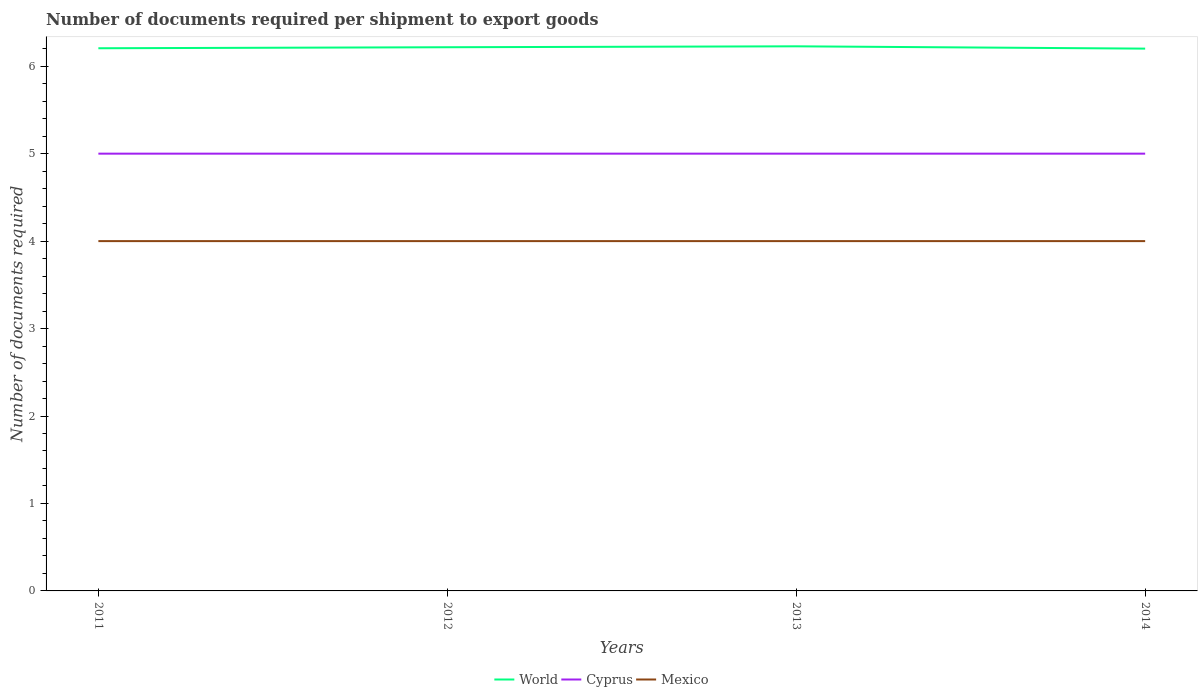How many different coloured lines are there?
Your response must be concise. 3. Does the line corresponding to World intersect with the line corresponding to Cyprus?
Make the answer very short. No. Is the number of lines equal to the number of legend labels?
Offer a terse response. Yes. Across all years, what is the maximum number of documents required per shipment to export goods in Mexico?
Offer a very short reply. 4. In which year was the number of documents required per shipment to export goods in World maximum?
Ensure brevity in your answer.  2014. What is the total number of documents required per shipment to export goods in World in the graph?
Give a very brief answer. 0.02. What is the difference between the highest and the second highest number of documents required per shipment to export goods in Cyprus?
Offer a very short reply. 0. How many lines are there?
Offer a terse response. 3. Are the values on the major ticks of Y-axis written in scientific E-notation?
Your response must be concise. No. Does the graph contain grids?
Your response must be concise. No. How are the legend labels stacked?
Keep it short and to the point. Horizontal. What is the title of the graph?
Offer a terse response. Number of documents required per shipment to export goods. What is the label or title of the Y-axis?
Keep it short and to the point. Number of documents required. What is the Number of documents required of World in 2011?
Your answer should be very brief. 6.21. What is the Number of documents required in Mexico in 2011?
Give a very brief answer. 4. What is the Number of documents required of World in 2012?
Your answer should be very brief. 6.22. What is the Number of documents required in Cyprus in 2012?
Offer a very short reply. 5. What is the Number of documents required of Mexico in 2012?
Provide a succinct answer. 4. What is the Number of documents required of World in 2013?
Keep it short and to the point. 6.23. What is the Number of documents required in Mexico in 2013?
Give a very brief answer. 4. What is the Number of documents required in World in 2014?
Your answer should be compact. 6.2. What is the Number of documents required in Mexico in 2014?
Ensure brevity in your answer.  4. Across all years, what is the maximum Number of documents required in World?
Provide a short and direct response. 6.23. Across all years, what is the minimum Number of documents required in World?
Keep it short and to the point. 6.2. Across all years, what is the minimum Number of documents required in Cyprus?
Keep it short and to the point. 5. Across all years, what is the minimum Number of documents required in Mexico?
Offer a very short reply. 4. What is the total Number of documents required of World in the graph?
Keep it short and to the point. 24.85. What is the difference between the Number of documents required of World in 2011 and that in 2012?
Provide a short and direct response. -0.01. What is the difference between the Number of documents required of Cyprus in 2011 and that in 2012?
Keep it short and to the point. 0. What is the difference between the Number of documents required in World in 2011 and that in 2013?
Your answer should be compact. -0.02. What is the difference between the Number of documents required in Mexico in 2011 and that in 2013?
Keep it short and to the point. 0. What is the difference between the Number of documents required in World in 2011 and that in 2014?
Your response must be concise. 0. What is the difference between the Number of documents required in World in 2012 and that in 2013?
Your answer should be very brief. -0.01. What is the difference between the Number of documents required in World in 2012 and that in 2014?
Provide a succinct answer. 0.02. What is the difference between the Number of documents required of Cyprus in 2012 and that in 2014?
Your answer should be very brief. 0. What is the difference between the Number of documents required of Mexico in 2012 and that in 2014?
Offer a terse response. 0. What is the difference between the Number of documents required in World in 2013 and that in 2014?
Offer a terse response. 0.03. What is the difference between the Number of documents required in World in 2011 and the Number of documents required in Cyprus in 2012?
Offer a terse response. 1.21. What is the difference between the Number of documents required of World in 2011 and the Number of documents required of Mexico in 2012?
Provide a short and direct response. 2.21. What is the difference between the Number of documents required of Cyprus in 2011 and the Number of documents required of Mexico in 2012?
Ensure brevity in your answer.  1. What is the difference between the Number of documents required in World in 2011 and the Number of documents required in Cyprus in 2013?
Your answer should be compact. 1.21. What is the difference between the Number of documents required of World in 2011 and the Number of documents required of Mexico in 2013?
Keep it short and to the point. 2.21. What is the difference between the Number of documents required of World in 2011 and the Number of documents required of Cyprus in 2014?
Your response must be concise. 1.21. What is the difference between the Number of documents required of World in 2011 and the Number of documents required of Mexico in 2014?
Provide a short and direct response. 2.21. What is the difference between the Number of documents required of World in 2012 and the Number of documents required of Cyprus in 2013?
Ensure brevity in your answer.  1.22. What is the difference between the Number of documents required of World in 2012 and the Number of documents required of Mexico in 2013?
Give a very brief answer. 2.22. What is the difference between the Number of documents required in World in 2012 and the Number of documents required in Cyprus in 2014?
Your answer should be compact. 1.22. What is the difference between the Number of documents required in World in 2012 and the Number of documents required in Mexico in 2014?
Make the answer very short. 2.22. What is the difference between the Number of documents required in World in 2013 and the Number of documents required in Cyprus in 2014?
Keep it short and to the point. 1.23. What is the difference between the Number of documents required of World in 2013 and the Number of documents required of Mexico in 2014?
Give a very brief answer. 2.23. What is the difference between the Number of documents required of Cyprus in 2013 and the Number of documents required of Mexico in 2014?
Your answer should be very brief. 1. What is the average Number of documents required in World per year?
Keep it short and to the point. 6.21. What is the average Number of documents required of Mexico per year?
Provide a short and direct response. 4. In the year 2011, what is the difference between the Number of documents required in World and Number of documents required in Cyprus?
Ensure brevity in your answer.  1.21. In the year 2011, what is the difference between the Number of documents required in World and Number of documents required in Mexico?
Your answer should be very brief. 2.21. In the year 2011, what is the difference between the Number of documents required of Cyprus and Number of documents required of Mexico?
Give a very brief answer. 1. In the year 2012, what is the difference between the Number of documents required in World and Number of documents required in Cyprus?
Offer a terse response. 1.22. In the year 2012, what is the difference between the Number of documents required of World and Number of documents required of Mexico?
Provide a short and direct response. 2.22. In the year 2013, what is the difference between the Number of documents required in World and Number of documents required in Cyprus?
Keep it short and to the point. 1.23. In the year 2013, what is the difference between the Number of documents required of World and Number of documents required of Mexico?
Offer a very short reply. 2.23. In the year 2013, what is the difference between the Number of documents required of Cyprus and Number of documents required of Mexico?
Offer a very short reply. 1. In the year 2014, what is the difference between the Number of documents required of World and Number of documents required of Cyprus?
Provide a succinct answer. 1.2. In the year 2014, what is the difference between the Number of documents required in World and Number of documents required in Mexico?
Make the answer very short. 2.2. What is the ratio of the Number of documents required in World in 2011 to that in 2013?
Your answer should be very brief. 1. What is the ratio of the Number of documents required in Cyprus in 2011 to that in 2013?
Offer a terse response. 1. What is the ratio of the Number of documents required of Mexico in 2011 to that in 2013?
Your answer should be very brief. 1. What is the ratio of the Number of documents required of Mexico in 2011 to that in 2014?
Your response must be concise. 1. What is the ratio of the Number of documents required of Mexico in 2012 to that in 2013?
Your answer should be compact. 1. What is the ratio of the Number of documents required of World in 2013 to that in 2014?
Offer a terse response. 1. What is the difference between the highest and the second highest Number of documents required of World?
Your answer should be very brief. 0.01. What is the difference between the highest and the second highest Number of documents required in Mexico?
Offer a terse response. 0. What is the difference between the highest and the lowest Number of documents required in World?
Your answer should be compact. 0.03. What is the difference between the highest and the lowest Number of documents required in Cyprus?
Give a very brief answer. 0. 